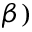Convert formula to latex. <formula><loc_0><loc_0><loc_500><loc_500>\beta )</formula> 